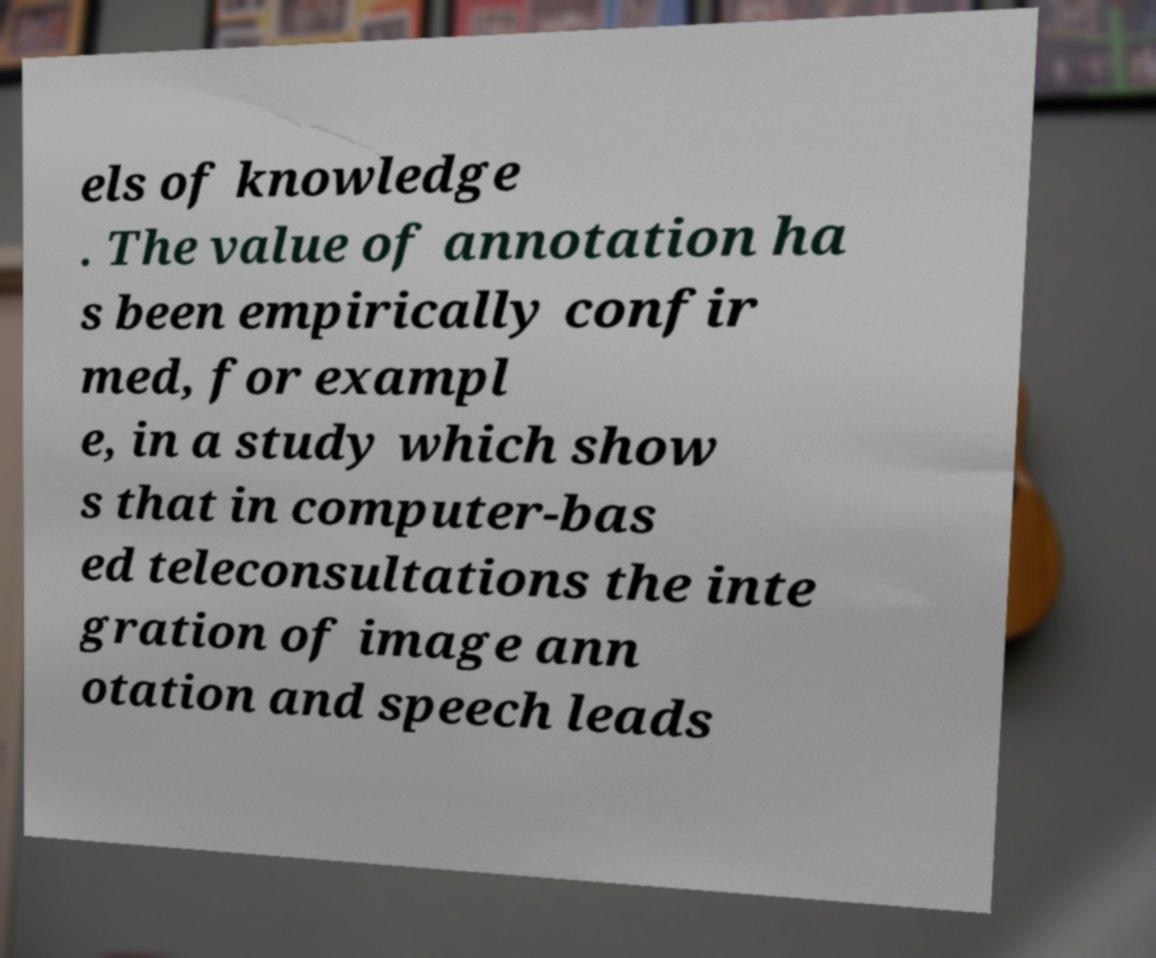There's text embedded in this image that I need extracted. Can you transcribe it verbatim? els of knowledge . The value of annotation ha s been empirically confir med, for exampl e, in a study which show s that in computer-bas ed teleconsultations the inte gration of image ann otation and speech leads 